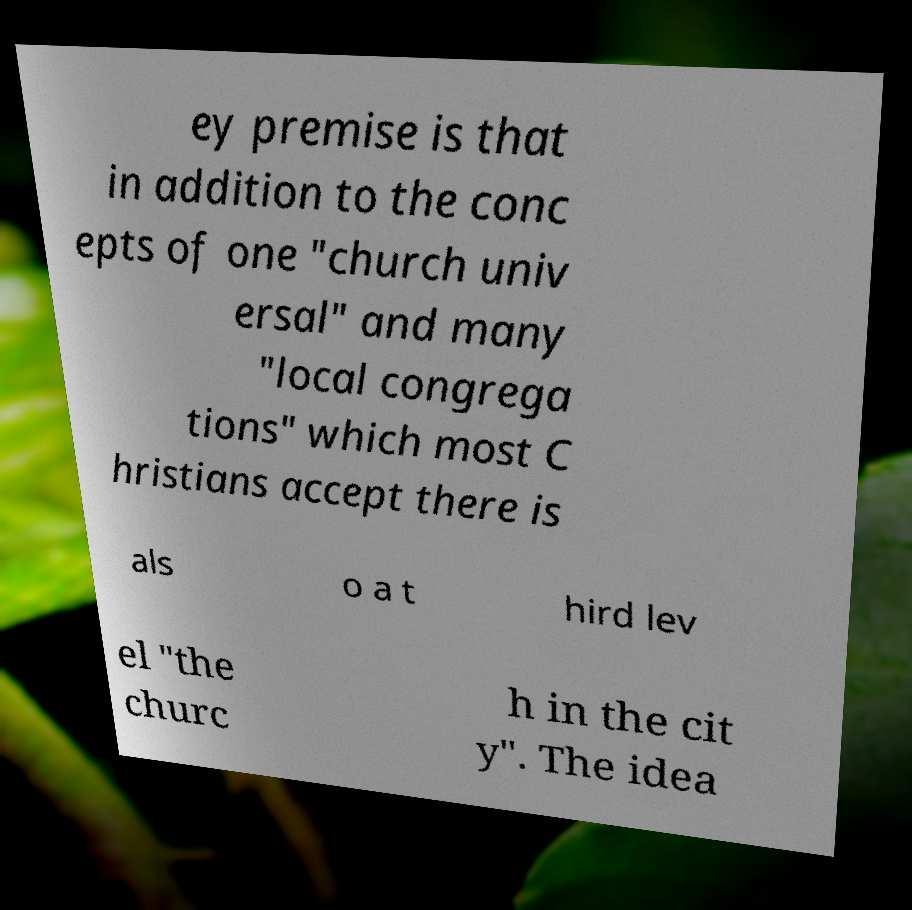What messages or text are displayed in this image? I need them in a readable, typed format. ey premise is that in addition to the conc epts of one "church univ ersal" and many "local congrega tions" which most C hristians accept there is als o a t hird lev el "the churc h in the cit y". The idea 